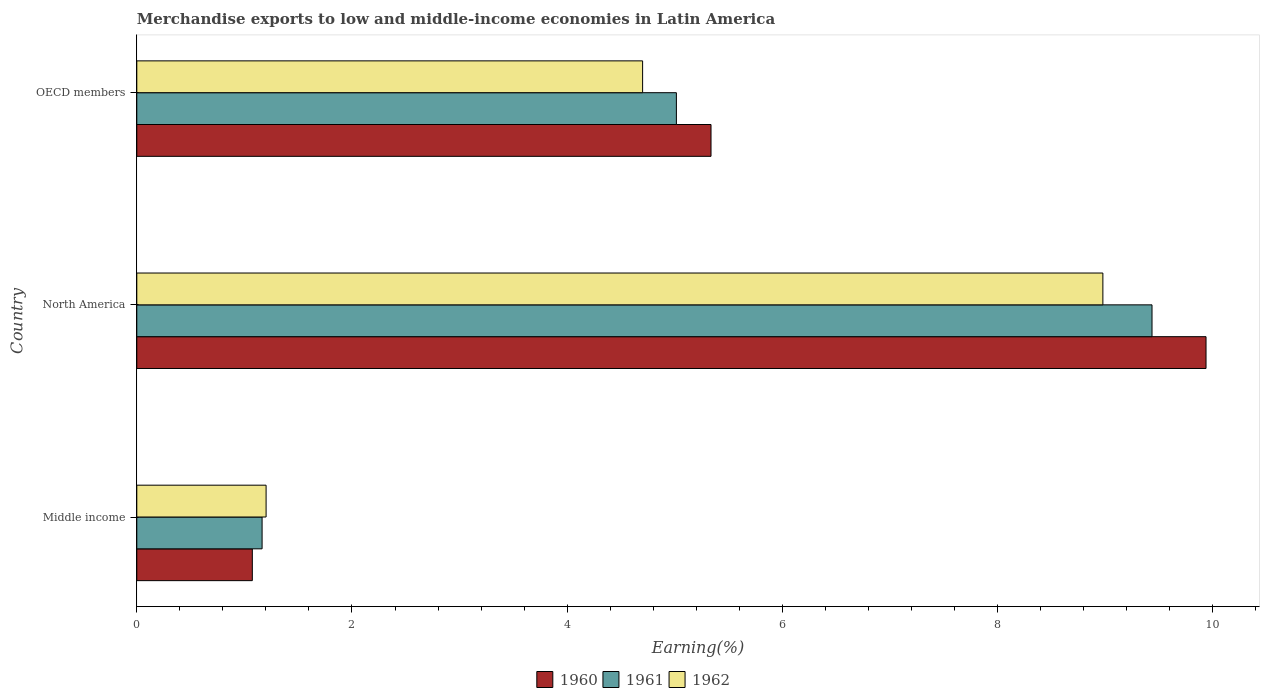How many different coloured bars are there?
Your answer should be compact. 3. How many groups of bars are there?
Your answer should be compact. 3. Are the number of bars per tick equal to the number of legend labels?
Your response must be concise. Yes. What is the label of the 2nd group of bars from the top?
Keep it short and to the point. North America. What is the percentage of amount earned from merchandise exports in 1961 in Middle income?
Make the answer very short. 1.16. Across all countries, what is the maximum percentage of amount earned from merchandise exports in 1962?
Keep it short and to the point. 8.98. Across all countries, what is the minimum percentage of amount earned from merchandise exports in 1962?
Provide a succinct answer. 1.2. In which country was the percentage of amount earned from merchandise exports in 1960 minimum?
Your answer should be very brief. Middle income. What is the total percentage of amount earned from merchandise exports in 1960 in the graph?
Provide a short and direct response. 16.35. What is the difference between the percentage of amount earned from merchandise exports in 1960 in Middle income and that in North America?
Make the answer very short. -8.86. What is the difference between the percentage of amount earned from merchandise exports in 1962 in Middle income and the percentage of amount earned from merchandise exports in 1961 in OECD members?
Offer a very short reply. -3.81. What is the average percentage of amount earned from merchandise exports in 1960 per country?
Your answer should be compact. 5.45. What is the difference between the percentage of amount earned from merchandise exports in 1961 and percentage of amount earned from merchandise exports in 1960 in OECD members?
Make the answer very short. -0.32. What is the ratio of the percentage of amount earned from merchandise exports in 1962 in Middle income to that in North America?
Offer a terse response. 0.13. What is the difference between the highest and the second highest percentage of amount earned from merchandise exports in 1961?
Provide a short and direct response. 4.42. What is the difference between the highest and the lowest percentage of amount earned from merchandise exports in 1961?
Offer a terse response. 8.27. Is the sum of the percentage of amount earned from merchandise exports in 1962 in Middle income and OECD members greater than the maximum percentage of amount earned from merchandise exports in 1960 across all countries?
Provide a short and direct response. No. What does the 2nd bar from the top in Middle income represents?
Your answer should be very brief. 1961. What does the 1st bar from the bottom in North America represents?
Provide a succinct answer. 1960. How many bars are there?
Keep it short and to the point. 9. How many countries are there in the graph?
Your answer should be compact. 3. What is the difference between two consecutive major ticks on the X-axis?
Provide a short and direct response. 2. Are the values on the major ticks of X-axis written in scientific E-notation?
Your answer should be compact. No. Does the graph contain grids?
Offer a very short reply. No. Where does the legend appear in the graph?
Provide a short and direct response. Bottom center. What is the title of the graph?
Your answer should be very brief. Merchandise exports to low and middle-income economies in Latin America. What is the label or title of the X-axis?
Provide a succinct answer. Earning(%). What is the Earning(%) in 1960 in Middle income?
Your response must be concise. 1.07. What is the Earning(%) in 1961 in Middle income?
Offer a very short reply. 1.16. What is the Earning(%) in 1962 in Middle income?
Your response must be concise. 1.2. What is the Earning(%) in 1960 in North America?
Make the answer very short. 9.94. What is the Earning(%) of 1961 in North America?
Keep it short and to the point. 9.44. What is the Earning(%) in 1962 in North America?
Your response must be concise. 8.98. What is the Earning(%) in 1960 in OECD members?
Your answer should be very brief. 5.34. What is the Earning(%) in 1961 in OECD members?
Ensure brevity in your answer.  5.02. What is the Earning(%) of 1962 in OECD members?
Offer a terse response. 4.7. Across all countries, what is the maximum Earning(%) in 1960?
Your answer should be very brief. 9.94. Across all countries, what is the maximum Earning(%) in 1961?
Provide a short and direct response. 9.44. Across all countries, what is the maximum Earning(%) of 1962?
Your answer should be compact. 8.98. Across all countries, what is the minimum Earning(%) in 1960?
Your response must be concise. 1.07. Across all countries, what is the minimum Earning(%) of 1961?
Make the answer very short. 1.16. Across all countries, what is the minimum Earning(%) of 1962?
Offer a very short reply. 1.2. What is the total Earning(%) of 1960 in the graph?
Your answer should be very brief. 16.35. What is the total Earning(%) of 1961 in the graph?
Make the answer very short. 15.62. What is the total Earning(%) in 1962 in the graph?
Keep it short and to the point. 14.88. What is the difference between the Earning(%) of 1960 in Middle income and that in North America?
Ensure brevity in your answer.  -8.86. What is the difference between the Earning(%) of 1961 in Middle income and that in North America?
Offer a terse response. -8.27. What is the difference between the Earning(%) in 1962 in Middle income and that in North America?
Ensure brevity in your answer.  -7.78. What is the difference between the Earning(%) in 1960 in Middle income and that in OECD members?
Offer a terse response. -4.26. What is the difference between the Earning(%) of 1961 in Middle income and that in OECD members?
Offer a very short reply. -3.85. What is the difference between the Earning(%) in 1962 in Middle income and that in OECD members?
Keep it short and to the point. -3.5. What is the difference between the Earning(%) of 1960 in North America and that in OECD members?
Provide a succinct answer. 4.6. What is the difference between the Earning(%) in 1961 in North America and that in OECD members?
Ensure brevity in your answer.  4.42. What is the difference between the Earning(%) of 1962 in North America and that in OECD members?
Give a very brief answer. 4.28. What is the difference between the Earning(%) of 1960 in Middle income and the Earning(%) of 1961 in North America?
Keep it short and to the point. -8.36. What is the difference between the Earning(%) in 1960 in Middle income and the Earning(%) in 1962 in North America?
Your answer should be very brief. -7.91. What is the difference between the Earning(%) in 1961 in Middle income and the Earning(%) in 1962 in North America?
Keep it short and to the point. -7.81. What is the difference between the Earning(%) in 1960 in Middle income and the Earning(%) in 1961 in OECD members?
Provide a short and direct response. -3.94. What is the difference between the Earning(%) in 1960 in Middle income and the Earning(%) in 1962 in OECD members?
Give a very brief answer. -3.63. What is the difference between the Earning(%) of 1961 in Middle income and the Earning(%) of 1962 in OECD members?
Provide a short and direct response. -3.54. What is the difference between the Earning(%) of 1960 in North America and the Earning(%) of 1961 in OECD members?
Offer a very short reply. 4.92. What is the difference between the Earning(%) of 1960 in North America and the Earning(%) of 1962 in OECD members?
Provide a short and direct response. 5.24. What is the difference between the Earning(%) of 1961 in North America and the Earning(%) of 1962 in OECD members?
Offer a very short reply. 4.73. What is the average Earning(%) of 1960 per country?
Your answer should be compact. 5.45. What is the average Earning(%) in 1961 per country?
Offer a terse response. 5.21. What is the average Earning(%) in 1962 per country?
Give a very brief answer. 4.96. What is the difference between the Earning(%) of 1960 and Earning(%) of 1961 in Middle income?
Provide a succinct answer. -0.09. What is the difference between the Earning(%) in 1960 and Earning(%) in 1962 in Middle income?
Provide a succinct answer. -0.13. What is the difference between the Earning(%) of 1961 and Earning(%) of 1962 in Middle income?
Your answer should be very brief. -0.04. What is the difference between the Earning(%) in 1960 and Earning(%) in 1961 in North America?
Your answer should be compact. 0.5. What is the difference between the Earning(%) of 1960 and Earning(%) of 1962 in North America?
Your response must be concise. 0.96. What is the difference between the Earning(%) of 1961 and Earning(%) of 1962 in North America?
Ensure brevity in your answer.  0.46. What is the difference between the Earning(%) of 1960 and Earning(%) of 1961 in OECD members?
Offer a terse response. 0.32. What is the difference between the Earning(%) of 1960 and Earning(%) of 1962 in OECD members?
Your answer should be compact. 0.64. What is the difference between the Earning(%) of 1961 and Earning(%) of 1962 in OECD members?
Offer a terse response. 0.31. What is the ratio of the Earning(%) of 1960 in Middle income to that in North America?
Make the answer very short. 0.11. What is the ratio of the Earning(%) of 1961 in Middle income to that in North America?
Ensure brevity in your answer.  0.12. What is the ratio of the Earning(%) in 1962 in Middle income to that in North America?
Give a very brief answer. 0.13. What is the ratio of the Earning(%) of 1960 in Middle income to that in OECD members?
Ensure brevity in your answer.  0.2. What is the ratio of the Earning(%) of 1961 in Middle income to that in OECD members?
Give a very brief answer. 0.23. What is the ratio of the Earning(%) of 1962 in Middle income to that in OECD members?
Offer a terse response. 0.26. What is the ratio of the Earning(%) in 1960 in North America to that in OECD members?
Offer a terse response. 1.86. What is the ratio of the Earning(%) of 1961 in North America to that in OECD members?
Your answer should be very brief. 1.88. What is the ratio of the Earning(%) in 1962 in North America to that in OECD members?
Give a very brief answer. 1.91. What is the difference between the highest and the second highest Earning(%) in 1960?
Make the answer very short. 4.6. What is the difference between the highest and the second highest Earning(%) in 1961?
Keep it short and to the point. 4.42. What is the difference between the highest and the second highest Earning(%) of 1962?
Keep it short and to the point. 4.28. What is the difference between the highest and the lowest Earning(%) of 1960?
Your response must be concise. 8.86. What is the difference between the highest and the lowest Earning(%) of 1961?
Offer a terse response. 8.27. What is the difference between the highest and the lowest Earning(%) in 1962?
Ensure brevity in your answer.  7.78. 